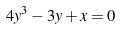<formula> <loc_0><loc_0><loc_500><loc_500>4 y ^ { 3 } - 3 y + x = 0</formula> 